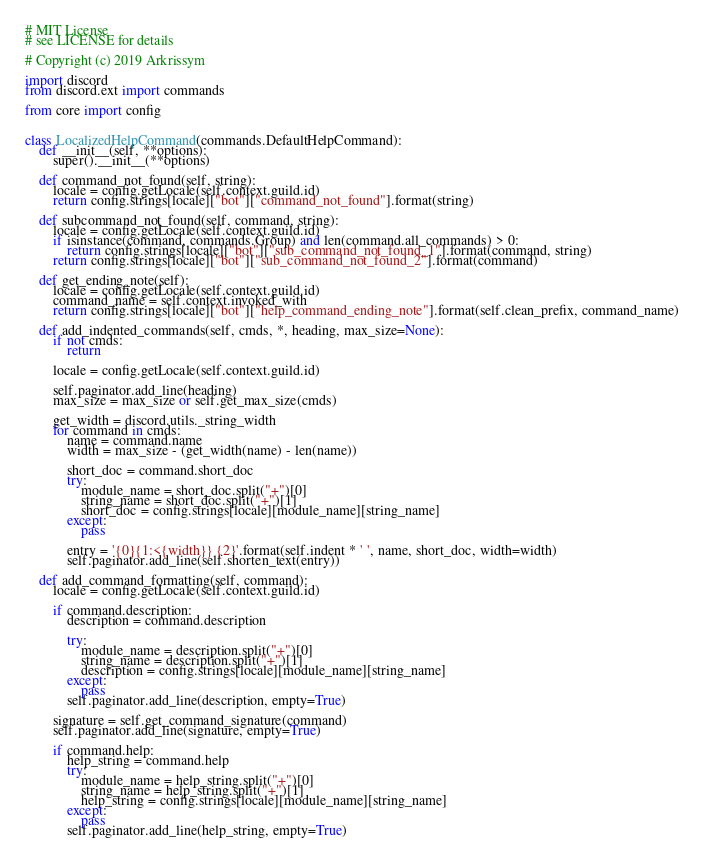Convert code to text. <code><loc_0><loc_0><loc_500><loc_500><_Python_># MIT License
# see LICENSE for details

# Copyright (c) 2019 Arkrissym

import discord
from discord.ext import commands

from core import config


class LocalizedHelpCommand(commands.DefaultHelpCommand):
	def __init__(self, **options):
		super().__init__(**options)

	def command_not_found(self, string):
		locale = config.getLocale(self.context.guild.id)
		return config.strings[locale]["bot"]["command_not_found"].format(string)

	def subcommand_not_found(self, command, string):
		locale = config.getLocale(self.context.guild.id)
		if isinstance(command, commands.Group) and len(command.all_commands) > 0:
			return config.strings[locale]["bot"]["sub_command_not_found_1"].format(command, string)
		return config.strings[locale]["bot"]["sub_command_not_found_2"].format(command)

	def get_ending_note(self):
		locale = config.getLocale(self.context.guild.id)
		command_name = self.context.invoked_with
		return config.strings[locale]["bot"]["help_command_ending_note"].format(self.clean_prefix, command_name)

	def add_indented_commands(self, cmds, *, heading, max_size=None):
		if not cmds:
			return

		locale = config.getLocale(self.context.guild.id)

		self.paginator.add_line(heading)
		max_size = max_size or self.get_max_size(cmds)

		get_width = discord.utils._string_width
		for command in cmds:
			name = command.name
			width = max_size - (get_width(name) - len(name))

			short_doc = command.short_doc
			try:
				module_name = short_doc.split("+")[0]
				string_name = short_doc.split("+")[1]
				short_doc = config.strings[locale][module_name][string_name]
			except:
				pass

			entry = '{0}{1:<{width}} {2}'.format(self.indent * ' ', name, short_doc, width=width)
			self.paginator.add_line(self.shorten_text(entry))

	def add_command_formatting(self, command):
		locale = config.getLocale(self.context.guild.id)

		if command.description:
			description = command.description

			try:
				module_name = description.split("+")[0]
				string_name = description.split("+")[1]
				description = config.strings[locale][module_name][string_name]
			except:
				pass
			self.paginator.add_line(description, empty=True)

		signature = self.get_command_signature(command)
		self.paginator.add_line(signature, empty=True)

		if command.help:
			help_string = command.help
			try:
				module_name = help_string.split("+")[0]
				string_name = help_string.split("+")[1]
				help_string = config.strings[locale][module_name][string_name]
			except:
				pass
			self.paginator.add_line(help_string, empty=True)
</code> 